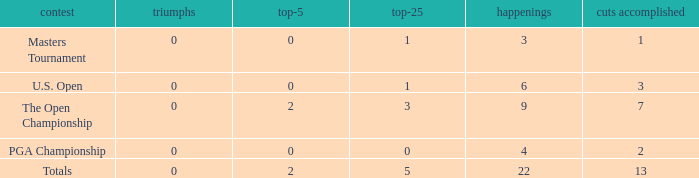What is the total number of wins for events with under 2 top-5s, under 5 top-25s, and more than 4 events played? 1.0. 